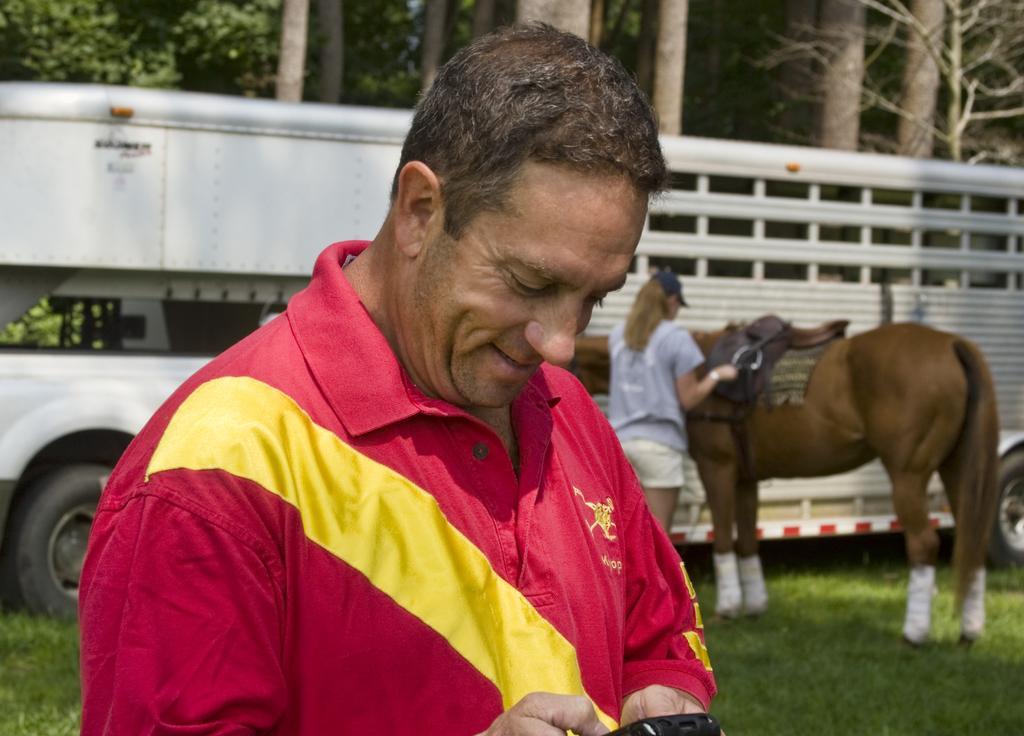Describe this image in one or two sentences. In this image i can see a person standing and holding a mobile in his hand, he is wearing a red shirt. In the back ground i can see a vehicle, a woman holding a horse, few trees and the grass. 